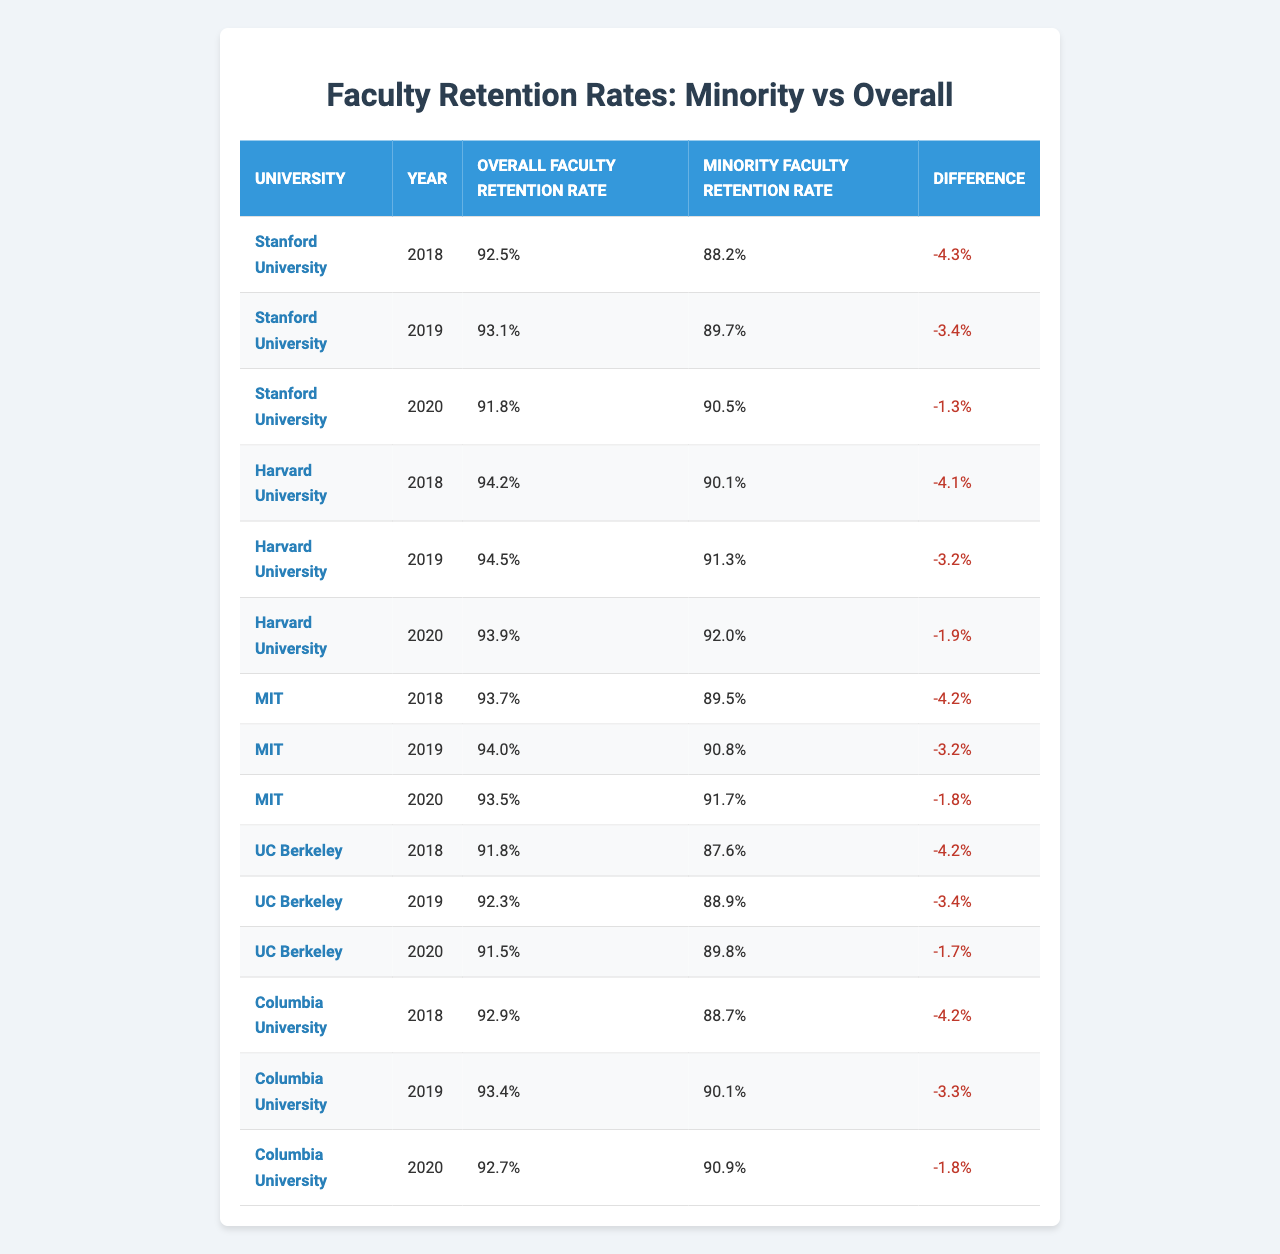What is the overall faculty retention rate at Harvard University in 2020? Looking at the table, I find the row for Harvard University in 2020. The "Overall Faculty Retention Rate" listed there is 93.9%.
Answer: 93.9% What is the difference between the minority faculty retention rate and the overall faculty retention rate for MIT in 2019? For MIT in 2019, the "Overall Faculty Retention Rate" is 94.0% and the "Minority Faculty Retention Rate" is 90.8%. The difference is 94.0% - 90.8% = 3.2%.
Answer: 3.2% Which university had the highest minority faculty retention rate in 2020? By comparing the "Minority Faculty Retention Rates" for 2020, I find that Columbia University has the highest rate at 90.9%.
Answer: Columbia University Was the retention rate for minority faculty members at UC Berkeley better than the overall retention rate in 2018? For UC Berkeley in 2018, the "Overall Faculty Retention Rate" is 91.8% and the "Minority Faculty Retention Rate" is 87.6%. Since 87.6% is less than 91.8%, the answer is no.
Answer: No What was the average minority faculty retention rate across all universities in 2019? First, I add the minority retention rates for each university in 2019: 89.7 (Stanford) + 91.3 (Harvard) + 90.8 (MIT) + 88.9 (UC Berkeley) + 90.1 (Columbia) = 450.8. There are 5 universities, so the average is 450.8 / 5 = 90.16%.
Answer: 90.16% In which year did Stanford University show the smallest difference between overall and minority faculty retention rates? I check the "Difference" column for Stanford University. The smallest difference is -1.3%, which occurred in 2020.
Answer: 2020 Is the overall faculty retention rate for UC Berkeley in 2019 higher than the average overall retention rate for all universities in 2019? From the data, UC Berkeley's overall retention rate in 2019 is 92.3%. To find the average for all universities in 2019, add their rates: 93.1 (Stanford) + 94.5 (Harvard) + 94.0 (MIT) + 92.3 (UC Berkeley) + 93.4 (Columbia) = 467.3, and divide by 5: 467.3 / 5 = 93.46%. Since 92.3% is less than 93.46%, the answer is no.
Answer: No 